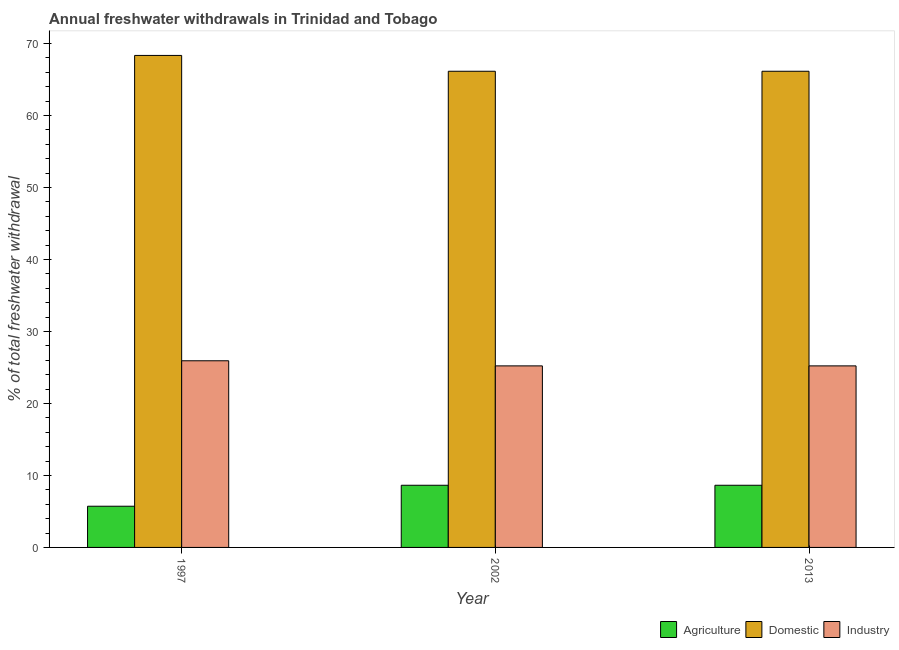How many different coloured bars are there?
Your answer should be compact. 3. Are the number of bars per tick equal to the number of legend labels?
Keep it short and to the point. Yes. Are the number of bars on each tick of the X-axis equal?
Give a very brief answer. Yes. What is the label of the 1st group of bars from the left?
Make the answer very short. 1997. What is the percentage of freshwater withdrawal for agriculture in 2002?
Keep it short and to the point. 8.64. Across all years, what is the maximum percentage of freshwater withdrawal for agriculture?
Your answer should be very brief. 8.64. Across all years, what is the minimum percentage of freshwater withdrawal for agriculture?
Your answer should be compact. 5.72. In which year was the percentage of freshwater withdrawal for industry minimum?
Offer a very short reply. 2002. What is the total percentage of freshwater withdrawal for domestic purposes in the graph?
Your response must be concise. 200.65. What is the difference between the percentage of freshwater withdrawal for industry in 1997 and that in 2002?
Keep it short and to the point. 0.71. What is the difference between the percentage of freshwater withdrawal for industry in 1997 and the percentage of freshwater withdrawal for domestic purposes in 2002?
Your response must be concise. 0.71. What is the average percentage of freshwater withdrawal for industry per year?
Provide a succinct answer. 25.46. In how many years, is the percentage of freshwater withdrawal for agriculture greater than 28 %?
Offer a terse response. 0. What is the ratio of the percentage of freshwater withdrawal for domestic purposes in 2002 to that in 2013?
Provide a short and direct response. 1. Is the percentage of freshwater withdrawal for agriculture in 1997 less than that in 2013?
Offer a terse response. Yes. Is the difference between the percentage of freshwater withdrawal for agriculture in 1997 and 2013 greater than the difference between the percentage of freshwater withdrawal for domestic purposes in 1997 and 2013?
Provide a succinct answer. No. What is the difference between the highest and the second highest percentage of freshwater withdrawal for domestic purposes?
Your answer should be very brief. 2.2. What is the difference between the highest and the lowest percentage of freshwater withdrawal for domestic purposes?
Your response must be concise. 2.2. Is the sum of the percentage of freshwater withdrawal for agriculture in 2002 and 2013 greater than the maximum percentage of freshwater withdrawal for domestic purposes across all years?
Make the answer very short. Yes. What does the 3rd bar from the left in 2002 represents?
Provide a succinct answer. Industry. What does the 1st bar from the right in 1997 represents?
Ensure brevity in your answer.  Industry. How many years are there in the graph?
Make the answer very short. 3. What is the difference between two consecutive major ticks on the Y-axis?
Your answer should be very brief. 10. Are the values on the major ticks of Y-axis written in scientific E-notation?
Your response must be concise. No. Does the graph contain grids?
Give a very brief answer. No. How are the legend labels stacked?
Ensure brevity in your answer.  Horizontal. What is the title of the graph?
Provide a succinct answer. Annual freshwater withdrawals in Trinidad and Tobago. Does "Food" appear as one of the legend labels in the graph?
Ensure brevity in your answer.  No. What is the label or title of the Y-axis?
Your answer should be very brief. % of total freshwater withdrawal. What is the % of total freshwater withdrawal of Agriculture in 1997?
Give a very brief answer. 5.72. What is the % of total freshwater withdrawal of Domestic in 1997?
Give a very brief answer. 68.35. What is the % of total freshwater withdrawal in Industry in 1997?
Make the answer very short. 25.93. What is the % of total freshwater withdrawal of Agriculture in 2002?
Your response must be concise. 8.64. What is the % of total freshwater withdrawal in Domestic in 2002?
Offer a terse response. 66.15. What is the % of total freshwater withdrawal in Industry in 2002?
Keep it short and to the point. 25.22. What is the % of total freshwater withdrawal of Agriculture in 2013?
Your answer should be very brief. 8.64. What is the % of total freshwater withdrawal of Domestic in 2013?
Offer a very short reply. 66.15. What is the % of total freshwater withdrawal in Industry in 2013?
Ensure brevity in your answer.  25.22. Across all years, what is the maximum % of total freshwater withdrawal in Agriculture?
Make the answer very short. 8.64. Across all years, what is the maximum % of total freshwater withdrawal of Domestic?
Your answer should be compact. 68.35. Across all years, what is the maximum % of total freshwater withdrawal of Industry?
Provide a short and direct response. 25.93. Across all years, what is the minimum % of total freshwater withdrawal of Agriculture?
Offer a terse response. 5.72. Across all years, what is the minimum % of total freshwater withdrawal of Domestic?
Provide a succinct answer. 66.15. Across all years, what is the minimum % of total freshwater withdrawal of Industry?
Offer a terse response. 25.22. What is the total % of total freshwater withdrawal in Agriculture in the graph?
Offer a very short reply. 23. What is the total % of total freshwater withdrawal of Domestic in the graph?
Your answer should be very brief. 200.65. What is the total % of total freshwater withdrawal in Industry in the graph?
Your answer should be very brief. 76.37. What is the difference between the % of total freshwater withdrawal of Agriculture in 1997 and that in 2002?
Offer a terse response. -2.91. What is the difference between the % of total freshwater withdrawal in Industry in 1997 and that in 2002?
Offer a terse response. 0.71. What is the difference between the % of total freshwater withdrawal in Agriculture in 1997 and that in 2013?
Your answer should be compact. -2.91. What is the difference between the % of total freshwater withdrawal of Industry in 1997 and that in 2013?
Your answer should be very brief. 0.71. What is the difference between the % of total freshwater withdrawal in Domestic in 2002 and that in 2013?
Your answer should be very brief. 0. What is the difference between the % of total freshwater withdrawal in Agriculture in 1997 and the % of total freshwater withdrawal in Domestic in 2002?
Offer a terse response. -60.43. What is the difference between the % of total freshwater withdrawal in Agriculture in 1997 and the % of total freshwater withdrawal in Industry in 2002?
Make the answer very short. -19.5. What is the difference between the % of total freshwater withdrawal of Domestic in 1997 and the % of total freshwater withdrawal of Industry in 2002?
Provide a succinct answer. 43.13. What is the difference between the % of total freshwater withdrawal of Agriculture in 1997 and the % of total freshwater withdrawal of Domestic in 2013?
Make the answer very short. -60.43. What is the difference between the % of total freshwater withdrawal in Agriculture in 1997 and the % of total freshwater withdrawal in Industry in 2013?
Your answer should be very brief. -19.5. What is the difference between the % of total freshwater withdrawal of Domestic in 1997 and the % of total freshwater withdrawal of Industry in 2013?
Your answer should be very brief. 43.13. What is the difference between the % of total freshwater withdrawal of Agriculture in 2002 and the % of total freshwater withdrawal of Domestic in 2013?
Your answer should be very brief. -57.51. What is the difference between the % of total freshwater withdrawal of Agriculture in 2002 and the % of total freshwater withdrawal of Industry in 2013?
Make the answer very short. -16.58. What is the difference between the % of total freshwater withdrawal in Domestic in 2002 and the % of total freshwater withdrawal in Industry in 2013?
Your answer should be compact. 40.93. What is the average % of total freshwater withdrawal of Agriculture per year?
Provide a succinct answer. 7.67. What is the average % of total freshwater withdrawal in Domestic per year?
Provide a succinct answer. 66.88. What is the average % of total freshwater withdrawal of Industry per year?
Make the answer very short. 25.46. In the year 1997, what is the difference between the % of total freshwater withdrawal of Agriculture and % of total freshwater withdrawal of Domestic?
Provide a short and direct response. -62.63. In the year 1997, what is the difference between the % of total freshwater withdrawal in Agriculture and % of total freshwater withdrawal in Industry?
Give a very brief answer. -20.21. In the year 1997, what is the difference between the % of total freshwater withdrawal in Domestic and % of total freshwater withdrawal in Industry?
Provide a short and direct response. 42.42. In the year 2002, what is the difference between the % of total freshwater withdrawal of Agriculture and % of total freshwater withdrawal of Domestic?
Offer a terse response. -57.51. In the year 2002, what is the difference between the % of total freshwater withdrawal in Agriculture and % of total freshwater withdrawal in Industry?
Make the answer very short. -16.58. In the year 2002, what is the difference between the % of total freshwater withdrawal of Domestic and % of total freshwater withdrawal of Industry?
Provide a short and direct response. 40.93. In the year 2013, what is the difference between the % of total freshwater withdrawal of Agriculture and % of total freshwater withdrawal of Domestic?
Ensure brevity in your answer.  -57.51. In the year 2013, what is the difference between the % of total freshwater withdrawal of Agriculture and % of total freshwater withdrawal of Industry?
Offer a very short reply. -16.58. In the year 2013, what is the difference between the % of total freshwater withdrawal in Domestic and % of total freshwater withdrawal in Industry?
Ensure brevity in your answer.  40.93. What is the ratio of the % of total freshwater withdrawal in Agriculture in 1997 to that in 2002?
Ensure brevity in your answer.  0.66. What is the ratio of the % of total freshwater withdrawal of Industry in 1997 to that in 2002?
Ensure brevity in your answer.  1.03. What is the ratio of the % of total freshwater withdrawal in Agriculture in 1997 to that in 2013?
Keep it short and to the point. 0.66. What is the ratio of the % of total freshwater withdrawal in Domestic in 1997 to that in 2013?
Your response must be concise. 1.03. What is the ratio of the % of total freshwater withdrawal of Industry in 1997 to that in 2013?
Give a very brief answer. 1.03. What is the difference between the highest and the second highest % of total freshwater withdrawal of Domestic?
Offer a very short reply. 2.2. What is the difference between the highest and the second highest % of total freshwater withdrawal of Industry?
Keep it short and to the point. 0.71. What is the difference between the highest and the lowest % of total freshwater withdrawal in Agriculture?
Ensure brevity in your answer.  2.91. What is the difference between the highest and the lowest % of total freshwater withdrawal in Domestic?
Offer a terse response. 2.2. What is the difference between the highest and the lowest % of total freshwater withdrawal in Industry?
Provide a succinct answer. 0.71. 